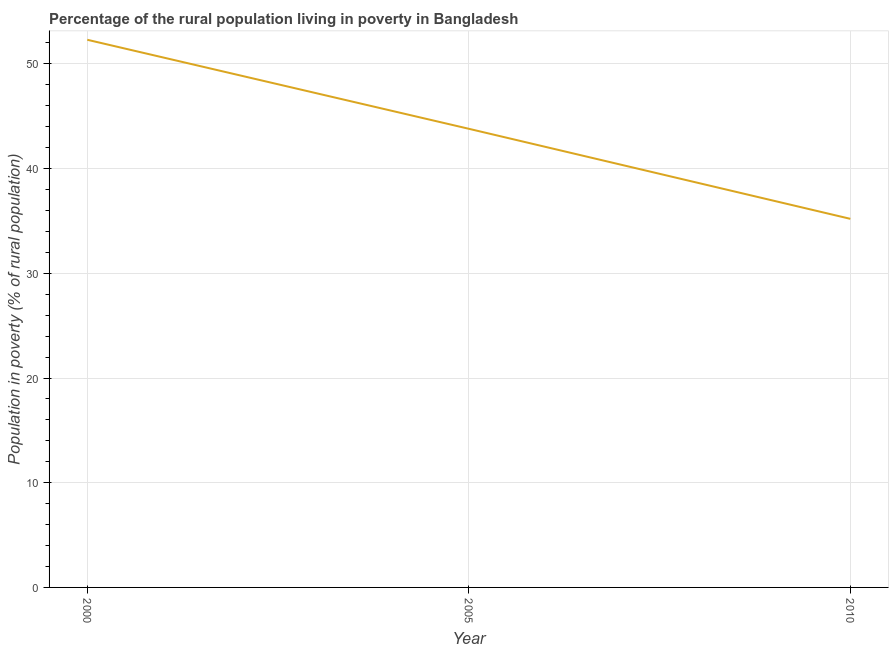What is the percentage of rural population living below poverty line in 2005?
Give a very brief answer. 43.8. Across all years, what is the maximum percentage of rural population living below poverty line?
Offer a very short reply. 52.3. Across all years, what is the minimum percentage of rural population living below poverty line?
Give a very brief answer. 35.2. In which year was the percentage of rural population living below poverty line maximum?
Provide a short and direct response. 2000. In which year was the percentage of rural population living below poverty line minimum?
Provide a succinct answer. 2010. What is the sum of the percentage of rural population living below poverty line?
Ensure brevity in your answer.  131.3. What is the difference between the percentage of rural population living below poverty line in 2005 and 2010?
Make the answer very short. 8.6. What is the average percentage of rural population living below poverty line per year?
Offer a very short reply. 43.77. What is the median percentage of rural population living below poverty line?
Provide a short and direct response. 43.8. Do a majority of the years between 2000 and 2005 (inclusive) have percentage of rural population living below poverty line greater than 4 %?
Ensure brevity in your answer.  Yes. What is the ratio of the percentage of rural population living below poverty line in 2000 to that in 2005?
Your answer should be compact. 1.19. Is the percentage of rural population living below poverty line in 2000 less than that in 2005?
Provide a succinct answer. No. What is the difference between the highest and the second highest percentage of rural population living below poverty line?
Provide a succinct answer. 8.5. What is the difference between the highest and the lowest percentage of rural population living below poverty line?
Provide a succinct answer. 17.1. Does the percentage of rural population living below poverty line monotonically increase over the years?
Make the answer very short. No. How many years are there in the graph?
Provide a succinct answer. 3. What is the difference between two consecutive major ticks on the Y-axis?
Give a very brief answer. 10. Are the values on the major ticks of Y-axis written in scientific E-notation?
Ensure brevity in your answer.  No. Does the graph contain any zero values?
Offer a terse response. No. What is the title of the graph?
Provide a short and direct response. Percentage of the rural population living in poverty in Bangladesh. What is the label or title of the X-axis?
Ensure brevity in your answer.  Year. What is the label or title of the Y-axis?
Keep it short and to the point. Population in poverty (% of rural population). What is the Population in poverty (% of rural population) in 2000?
Offer a very short reply. 52.3. What is the Population in poverty (% of rural population) in 2005?
Keep it short and to the point. 43.8. What is the Population in poverty (% of rural population) in 2010?
Make the answer very short. 35.2. What is the difference between the Population in poverty (% of rural population) in 2000 and 2005?
Your answer should be compact. 8.5. What is the difference between the Population in poverty (% of rural population) in 2005 and 2010?
Offer a terse response. 8.6. What is the ratio of the Population in poverty (% of rural population) in 2000 to that in 2005?
Give a very brief answer. 1.19. What is the ratio of the Population in poverty (% of rural population) in 2000 to that in 2010?
Make the answer very short. 1.49. What is the ratio of the Population in poverty (% of rural population) in 2005 to that in 2010?
Provide a short and direct response. 1.24. 